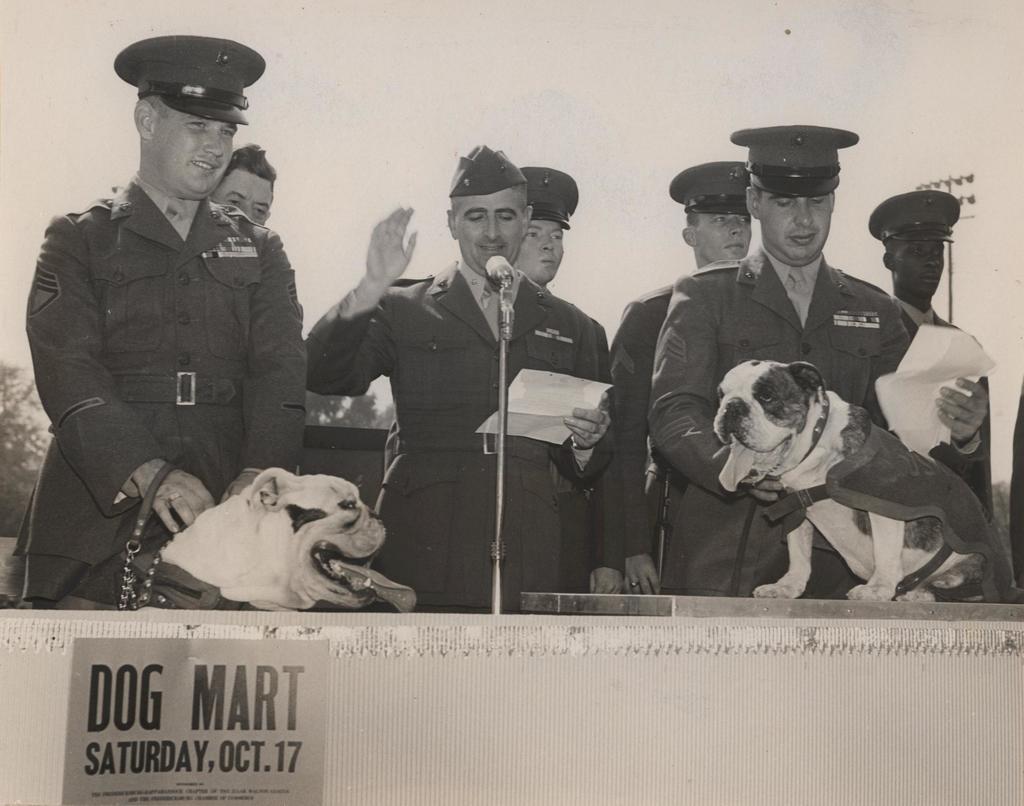In one or two sentences, can you explain what this image depicts? This picture describes about group of people who are all standing in front of microphone and there are some dogs in front of them in the middle of the image a person holding a piece of paper in the background we can see couple of trees and a pole. 